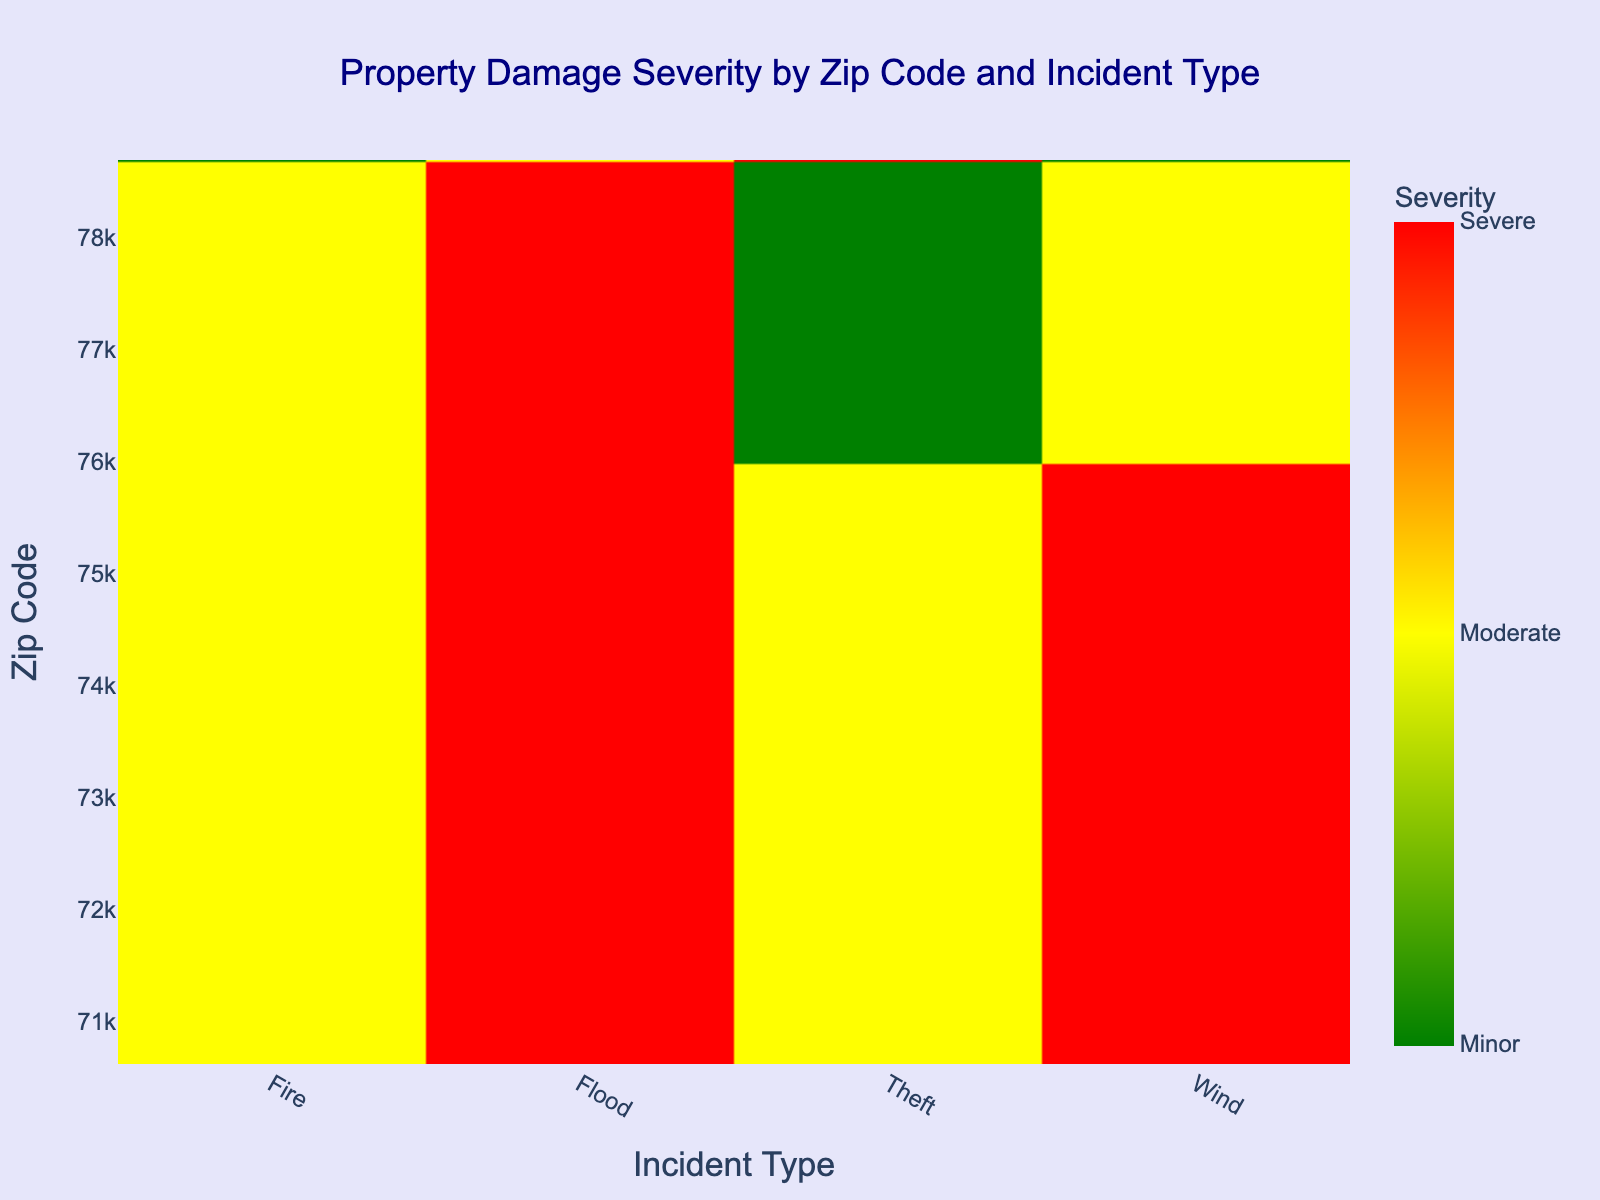What's the overall title of the heatmap? The overall title is positioned at the top center of the figure. By visually examining the title section, we can determine the title of the heatmap.
Answer: Property Damage Severity by Zip Code and Incident Type Which incident type in Zip Code 78665 has the highest severity level? By locating Zip Code 78665 on the y-axis and scanning horizontally across its row, we observe the colors corresponding to different incident types. The darkest/red cell represents the highest severity.
Answer: Wind How many incident types in Zip Code 73301 are categorized as Moderate or higher severity? Identify the row for Zip Code 73301, and examine the cells to count those with severity represented by yellow (Moderate) or red (Severe).
Answer: 3 What is the color associated with Minor severity? The color scale bar on the right side of the heatmap shows the correspondence between severity levels and colors. Minor severity is the first level on the gradient.
Answer: Green Which Zip Code has the least severe property damage for Flood incidents? By examining the Flood column and identifying the lightest shade (green corresponds to Minor), we determine which Zip Code has the least severe damage.
Answer: 78681 How does the severity of Fire incidents in Zip Code 78665 compare to that in Zip Code 73301? Locate the Fire column and compare the colors representing severity for Zip Code 78665 and Zip Code 73301. The more intense the color shade, the higher the severity.
Answer: 78665 is more severe than 73301 What is the average severity of Theft incidents across all Zip Codes? Note that Minor is 1, Moderate is 2, and Severe is 3. Sum the severity values for Theft incidents across all Zip Codes and then divide by the number of Zip Codes. [(1+3+2+1)/4]=1.75
Answer: 1.75 What colors are predominantly used in the heatmap, and what do they signify? Assess the overall color distribution in the heatmap. Each color correlates with a severity level: green for Minor, yellow for Moderate, and red for Severe.
Answer: Green, yellow, red Which incident type shows the highest variability in severity across different Zip Codes? Observe the range of colors within each column (incident type) and determine which has the greatest spread from green to red, indicating high variability.
Answer: Theft Is there any Zip Code that has no Severe property damage for any incident type? Scan each row for the presence of red cells (Severe). If a row lacks any red cell, it indicates no Severe damage.
Answer: 78681 